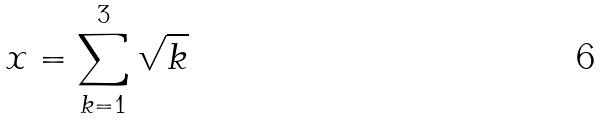Convert formula to latex. <formula><loc_0><loc_0><loc_500><loc_500>x = \sum _ { k = 1 } ^ { 3 } \sqrt { k }</formula> 